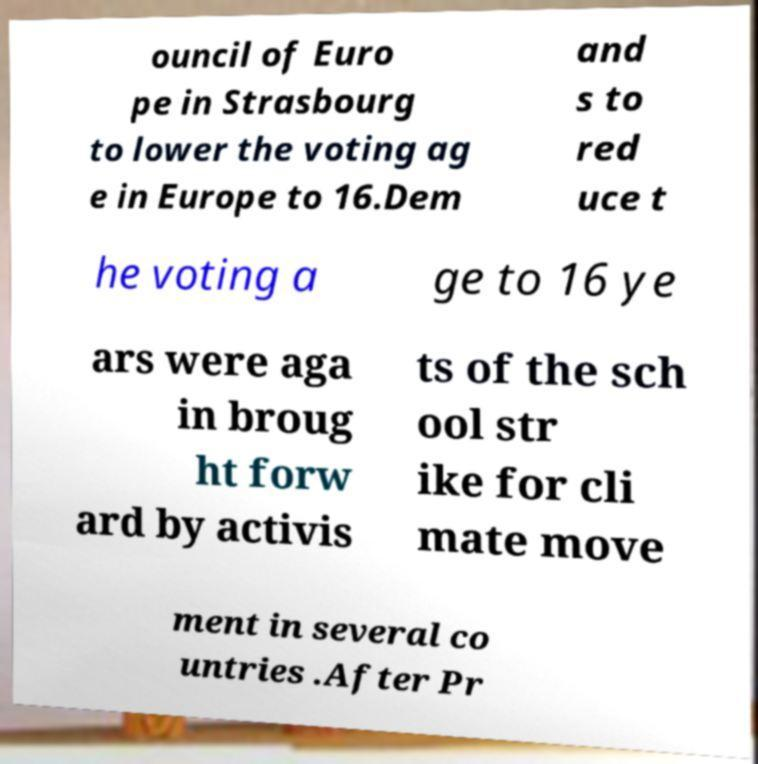Can you read and provide the text displayed in the image?This photo seems to have some interesting text. Can you extract and type it out for me? ouncil of Euro pe in Strasbourg to lower the voting ag e in Europe to 16.Dem and s to red uce t he voting a ge to 16 ye ars were aga in broug ht forw ard by activis ts of the sch ool str ike for cli mate move ment in several co untries .After Pr 